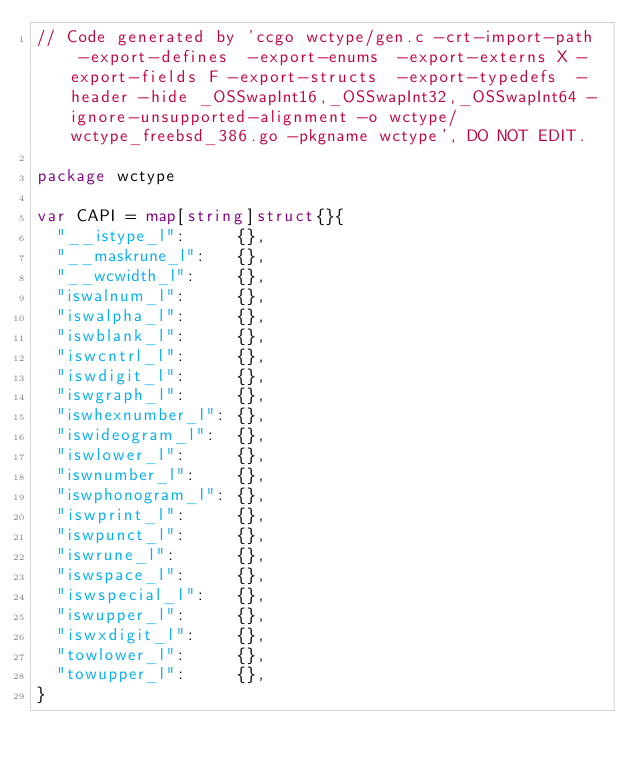<code> <loc_0><loc_0><loc_500><loc_500><_Go_>// Code generated by 'ccgo wctype/gen.c -crt-import-path  -export-defines  -export-enums  -export-externs X -export-fields F -export-structs  -export-typedefs  -header -hide _OSSwapInt16,_OSSwapInt32,_OSSwapInt64 -ignore-unsupported-alignment -o wctype/wctype_freebsd_386.go -pkgname wctype', DO NOT EDIT.

package wctype

var CAPI = map[string]struct{}{
	"__istype_l":     {},
	"__maskrune_l":   {},
	"__wcwidth_l":    {},
	"iswalnum_l":     {},
	"iswalpha_l":     {},
	"iswblank_l":     {},
	"iswcntrl_l":     {},
	"iswdigit_l":     {},
	"iswgraph_l":     {},
	"iswhexnumber_l": {},
	"iswideogram_l":  {},
	"iswlower_l":     {},
	"iswnumber_l":    {},
	"iswphonogram_l": {},
	"iswprint_l":     {},
	"iswpunct_l":     {},
	"iswrune_l":      {},
	"iswspace_l":     {},
	"iswspecial_l":   {},
	"iswupper_l":     {},
	"iswxdigit_l":    {},
	"towlower_l":     {},
	"towupper_l":     {},
}
</code> 